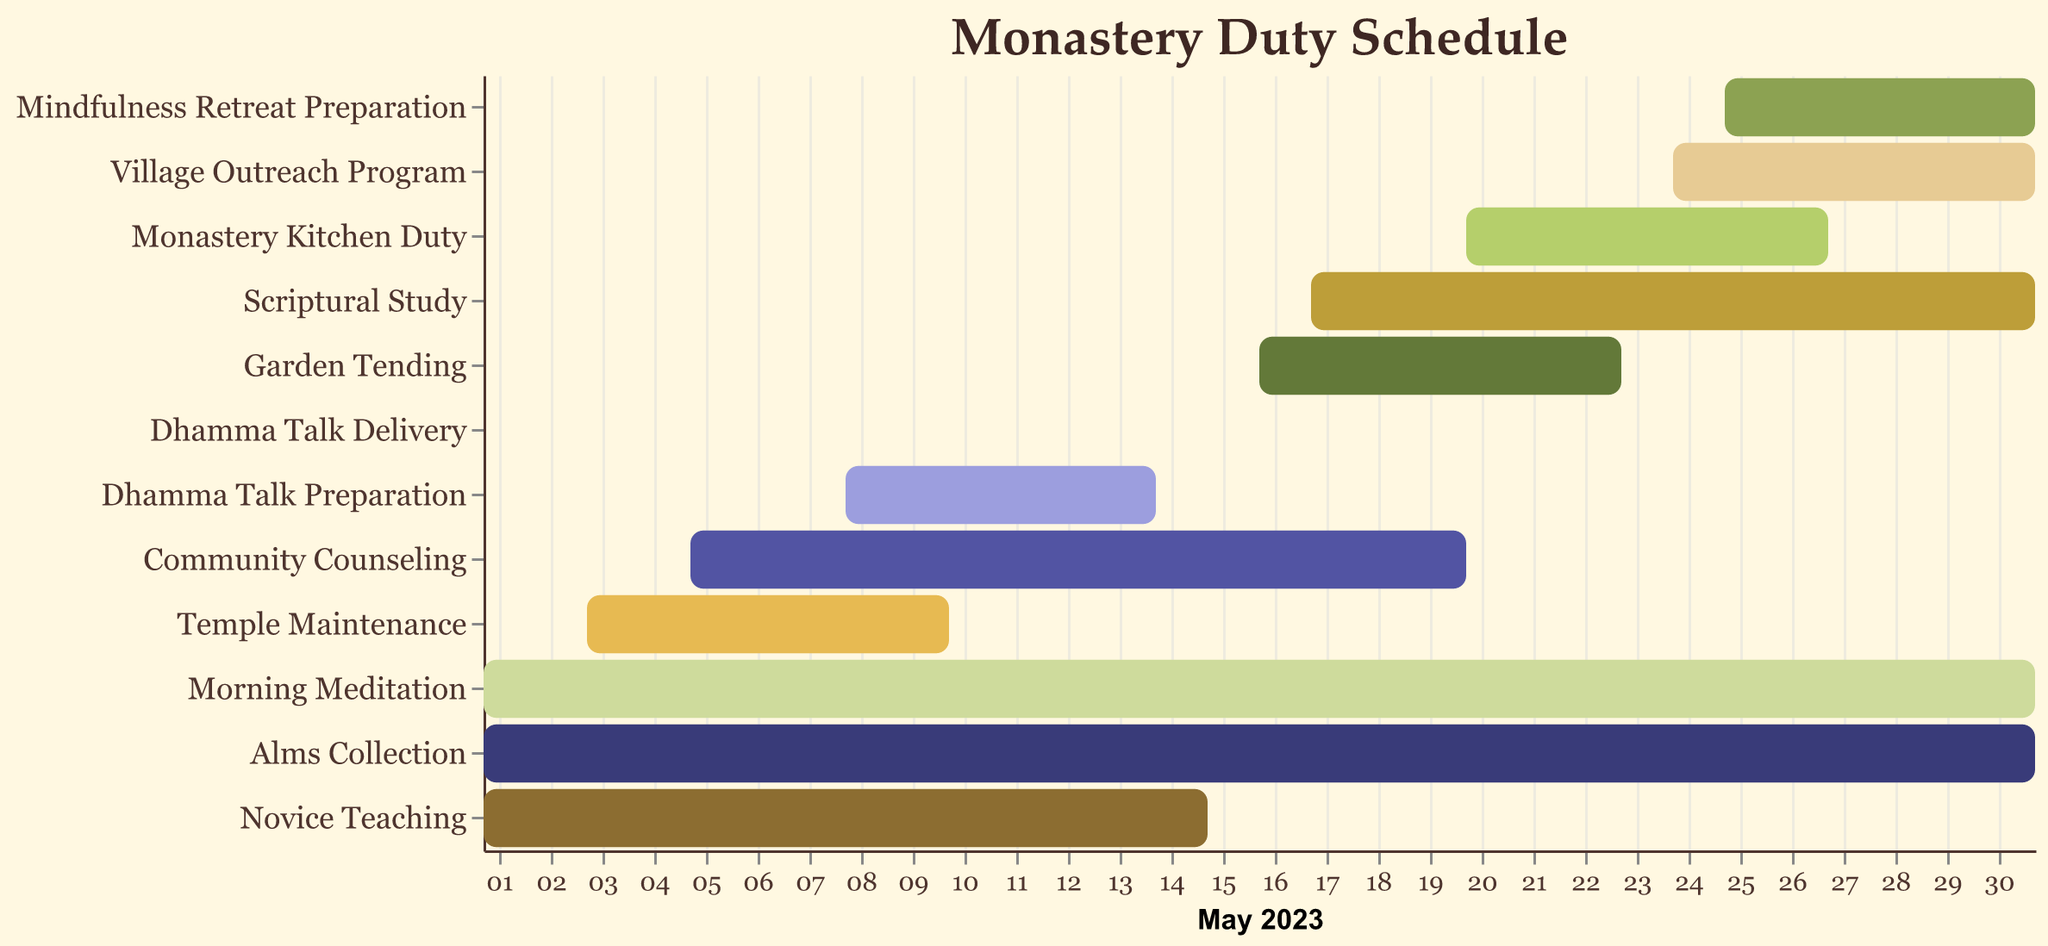Which task has the longest duration? To find the task with the longest duration, look at the length of each bar representing the tasks. The tasks that run from May 1 to May 31 are the longest.
Answer: Morning Meditation, Alms Collection Which tasks start on May 1 and end before May 31? Identify tasks that have the start date of May 1 and an end date earlier than May 31 by visually inspecting the bars. The tasks starting on May 1 and ending before May 31 are exactly two.
Answer: Novice Teaching What task overlaps the most with Temple Maintenance? First, identify the duration of Temple Maintenance (May 3 to May 10). Next, check which tasks intersect this time frame. The tasks which overlap the most with Temple Maintenance occur during varying periods between May 3 and May 10.
Answer: Community Counseling, Novice Teaching How many tasks are entirely completed before May 20? Identify the tasks that have their end date on or before May 20 by examining the end points of each task bar. Count these tasks. These tasks are: Novice Teaching, Temple Maintenance, Dhamma Talk Preparation, Dhamma Talk Delivery.
Answer: Four tasks What are the starting and ending dates of the Scriptural Study? Locate the bar for Scriptural Study and read off its start and end dates. It starts on May 17 and ends on May 31.
Answer: May 17 to May 31 Which two tasks have the same starting date but different end dates? Compare the start dates of each task pair and find the ones that begin on the same day but end on different dates. For example, tasks that start on May 1 but ending on different dates are Morning Meditation and Novice Teaching.
Answer: Morning Meditation and Novice Teaching (or Morning Meditation & Alms Collection) What tasks occur during the last week of May (May 25 to May 31)? Check which tasks' durations intersect with the period from May 25 to May 31 by looking at the range of each bar. Tasks that meet this criterion are Mindfulness Retreat Preparation, Village Outreach Program.
Answer: Mindfulness Retreat Preparation, Village Outreach Program On which specific day is the Dhamma Talk Delivery scheduled? Identify the unique task labeled Dhamma Talk Delivery and read its start and end date, since it is on a single day. This task is on May 15.
Answer: May 15 How does the length of Community Counseling compare to Garden Tending? Visual inspection of the length of the bars representing Community Counseling (May 5 to May 20) and Garden Tending (May 16 to May 23) shows that Community Counseling lasts longer than Garden Tending.
Answer: Community Counseling is longer than Garden Tending 